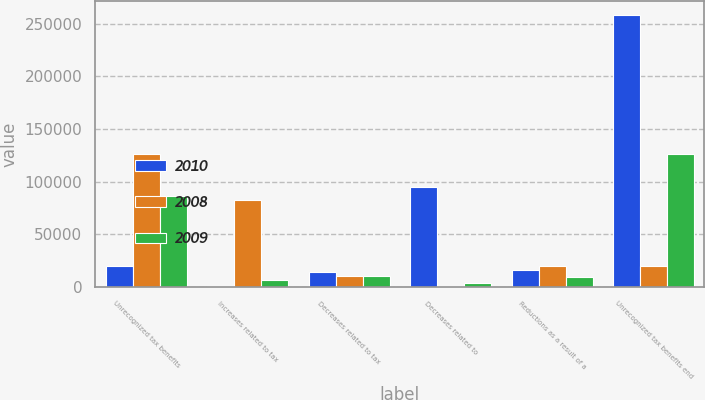Convert chart. <chart><loc_0><loc_0><loc_500><loc_500><stacked_bar_chart><ecel><fcel>Unrecognized tax benefits<fcel>Increases related to tax<fcel>Decreases related to tax<fcel>Decreases related to<fcel>Reductions as a result of a<fcel>Unrecognized tax benefits end<nl><fcel>2010<fcel>20322<fcel>1441<fcel>14025<fcel>94779<fcel>16094<fcel>258016<nl><fcel>2008<fcel>126299<fcel>82973<fcel>10414<fcel>1389<fcel>20322<fcel>20322<nl><fcel>2009<fcel>86209<fcel>6678<fcel>10951<fcel>4078<fcel>9206<fcel>126299<nl></chart> 